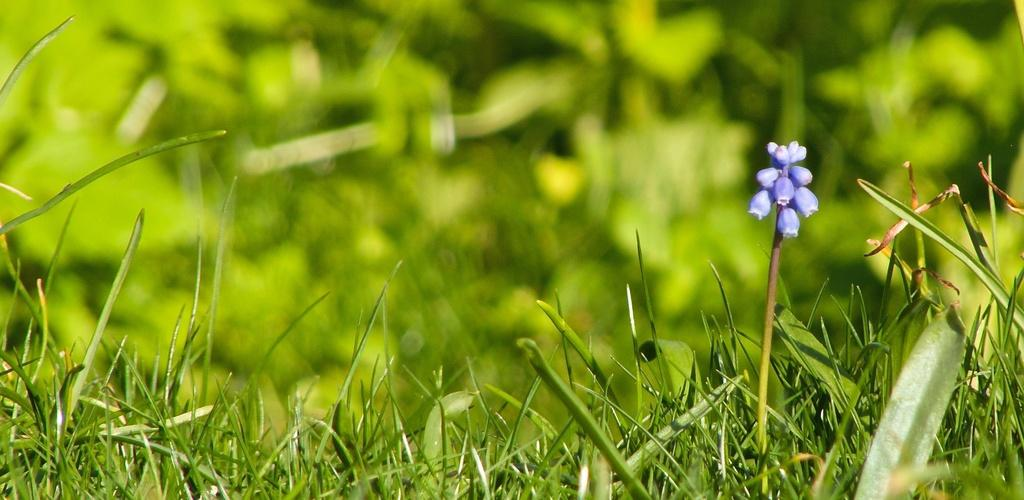What type of living organisms can be seen in the image? Plants can be seen in the image. What stage of growth are the plants in? The plants have buds, indicating they are in the early stages of growth. Can you describe the background of the image? The background of the image is blurred. What type of hole can be seen in the image? There is no hole present in the image; it features plants with buds and a blurred background. What kind of hat is worn by the plant in the image? There is no hat present in the image; it features plants with buds and a blurred background. 